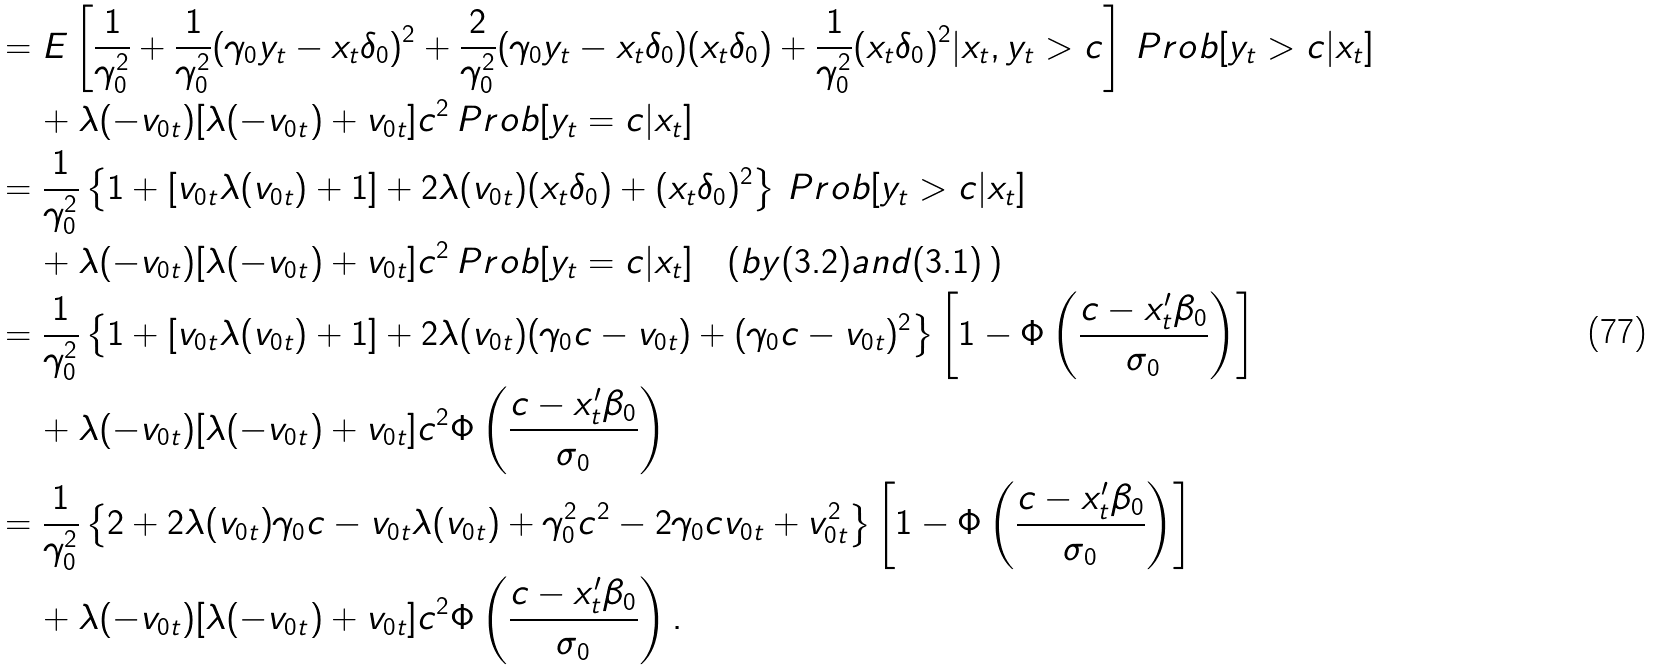<formula> <loc_0><loc_0><loc_500><loc_500>& = E \left [ \frac { 1 } { \gamma ^ { 2 } _ { 0 } } + \frac { 1 } { \gamma ^ { 2 } _ { 0 } } ( \gamma _ { 0 } y _ { t } - x _ { t } \delta _ { 0 } ) ^ { 2 } + \frac { 2 } { \gamma ^ { 2 } _ { 0 } } ( \gamma _ { 0 } y _ { t } - x _ { t } \delta _ { 0 } ) ( x _ { t } \delta _ { 0 } ) + \frac { 1 } { \gamma ^ { 2 } _ { 0 } } ( x _ { t } \delta _ { 0 } ) ^ { 2 } | x _ { t } , y _ { t } > c \right ] \, P r o b [ y _ { t } > c | x _ { t } ] \\ & \quad \, + \lambda ( - v _ { 0 t } ) [ \lambda ( - v _ { 0 t } ) + v _ { 0 t } ] c ^ { 2 } \, P r o b [ y _ { t } = c | x _ { t } ] \\ & = \frac { 1 } { \gamma ^ { 2 } _ { 0 } } \left \{ 1 + [ v _ { 0 t } \lambda ( v _ { 0 t } ) + 1 ] + 2 \lambda ( v _ { 0 t } ) ( x _ { t } \delta _ { 0 } ) + ( x _ { t } \delta _ { 0 } ) ^ { 2 } \right \} \, P r o b [ y _ { t } > c | x _ { t } ] \\ & \quad \, + \lambda ( - v _ { 0 t } ) [ \lambda ( - v _ { 0 t } ) + v _ { 0 t } ] c ^ { 2 } \, P r o b [ y _ { t } = c | x _ { t } ] \quad ( b y ( 3 . 2 ) a n d ( 3 . 1 ) \, ) \\ & = \frac { 1 } { \gamma ^ { 2 } _ { 0 } } \left \{ 1 + [ v _ { 0 t } \lambda ( v _ { 0 t } ) + 1 ] + 2 \lambda ( v _ { 0 t } ) ( \gamma _ { 0 } c - v _ { 0 t } ) + ( \gamma _ { 0 } c - v _ { 0 t } ) ^ { 2 } \right \} \left [ 1 - \Phi \left ( \frac { c - x ^ { \prime } _ { t } \beta _ { 0 } } { \sigma _ { 0 } } \right ) \right ] \\ & \quad \, + \lambda ( - v _ { 0 t } ) [ \lambda ( - v _ { 0 t } ) + v _ { 0 t } ] c ^ { 2 } \Phi \left ( \frac { c - x ^ { \prime } _ { t } \beta _ { 0 } } { \sigma _ { 0 } } \right ) \\ & = \frac { 1 } { \gamma ^ { 2 } _ { 0 } } \left \{ 2 + 2 \lambda ( v _ { 0 t } ) \gamma _ { 0 } c - v _ { 0 t } \lambda ( v _ { 0 t } ) + \gamma ^ { 2 } _ { 0 } c ^ { 2 } - 2 \gamma _ { 0 } c v _ { 0 t } + v ^ { 2 } _ { 0 t } \right \} \left [ 1 - \Phi \left ( \frac { c - x ^ { \prime } _ { t } \beta _ { 0 } } { \sigma _ { 0 } } \right ) \right ] \\ & \quad \, + \lambda ( - v _ { 0 t } ) [ \lambda ( - v _ { 0 t } ) + v _ { 0 t } ] c ^ { 2 } \Phi \left ( \frac { c - x ^ { \prime } _ { t } \beta _ { 0 } } { \sigma _ { 0 } } \right ) .</formula> 